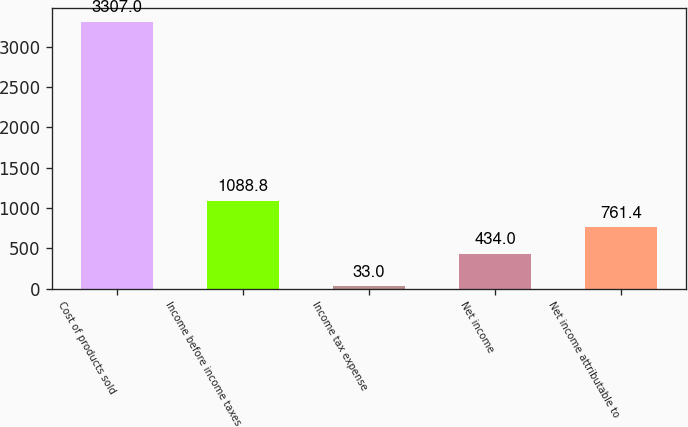Convert chart. <chart><loc_0><loc_0><loc_500><loc_500><bar_chart><fcel>Cost of products sold<fcel>Income before income taxes<fcel>Income tax expense<fcel>Net income<fcel>Net income attributable to<nl><fcel>3307<fcel>1088.8<fcel>33<fcel>434<fcel>761.4<nl></chart> 